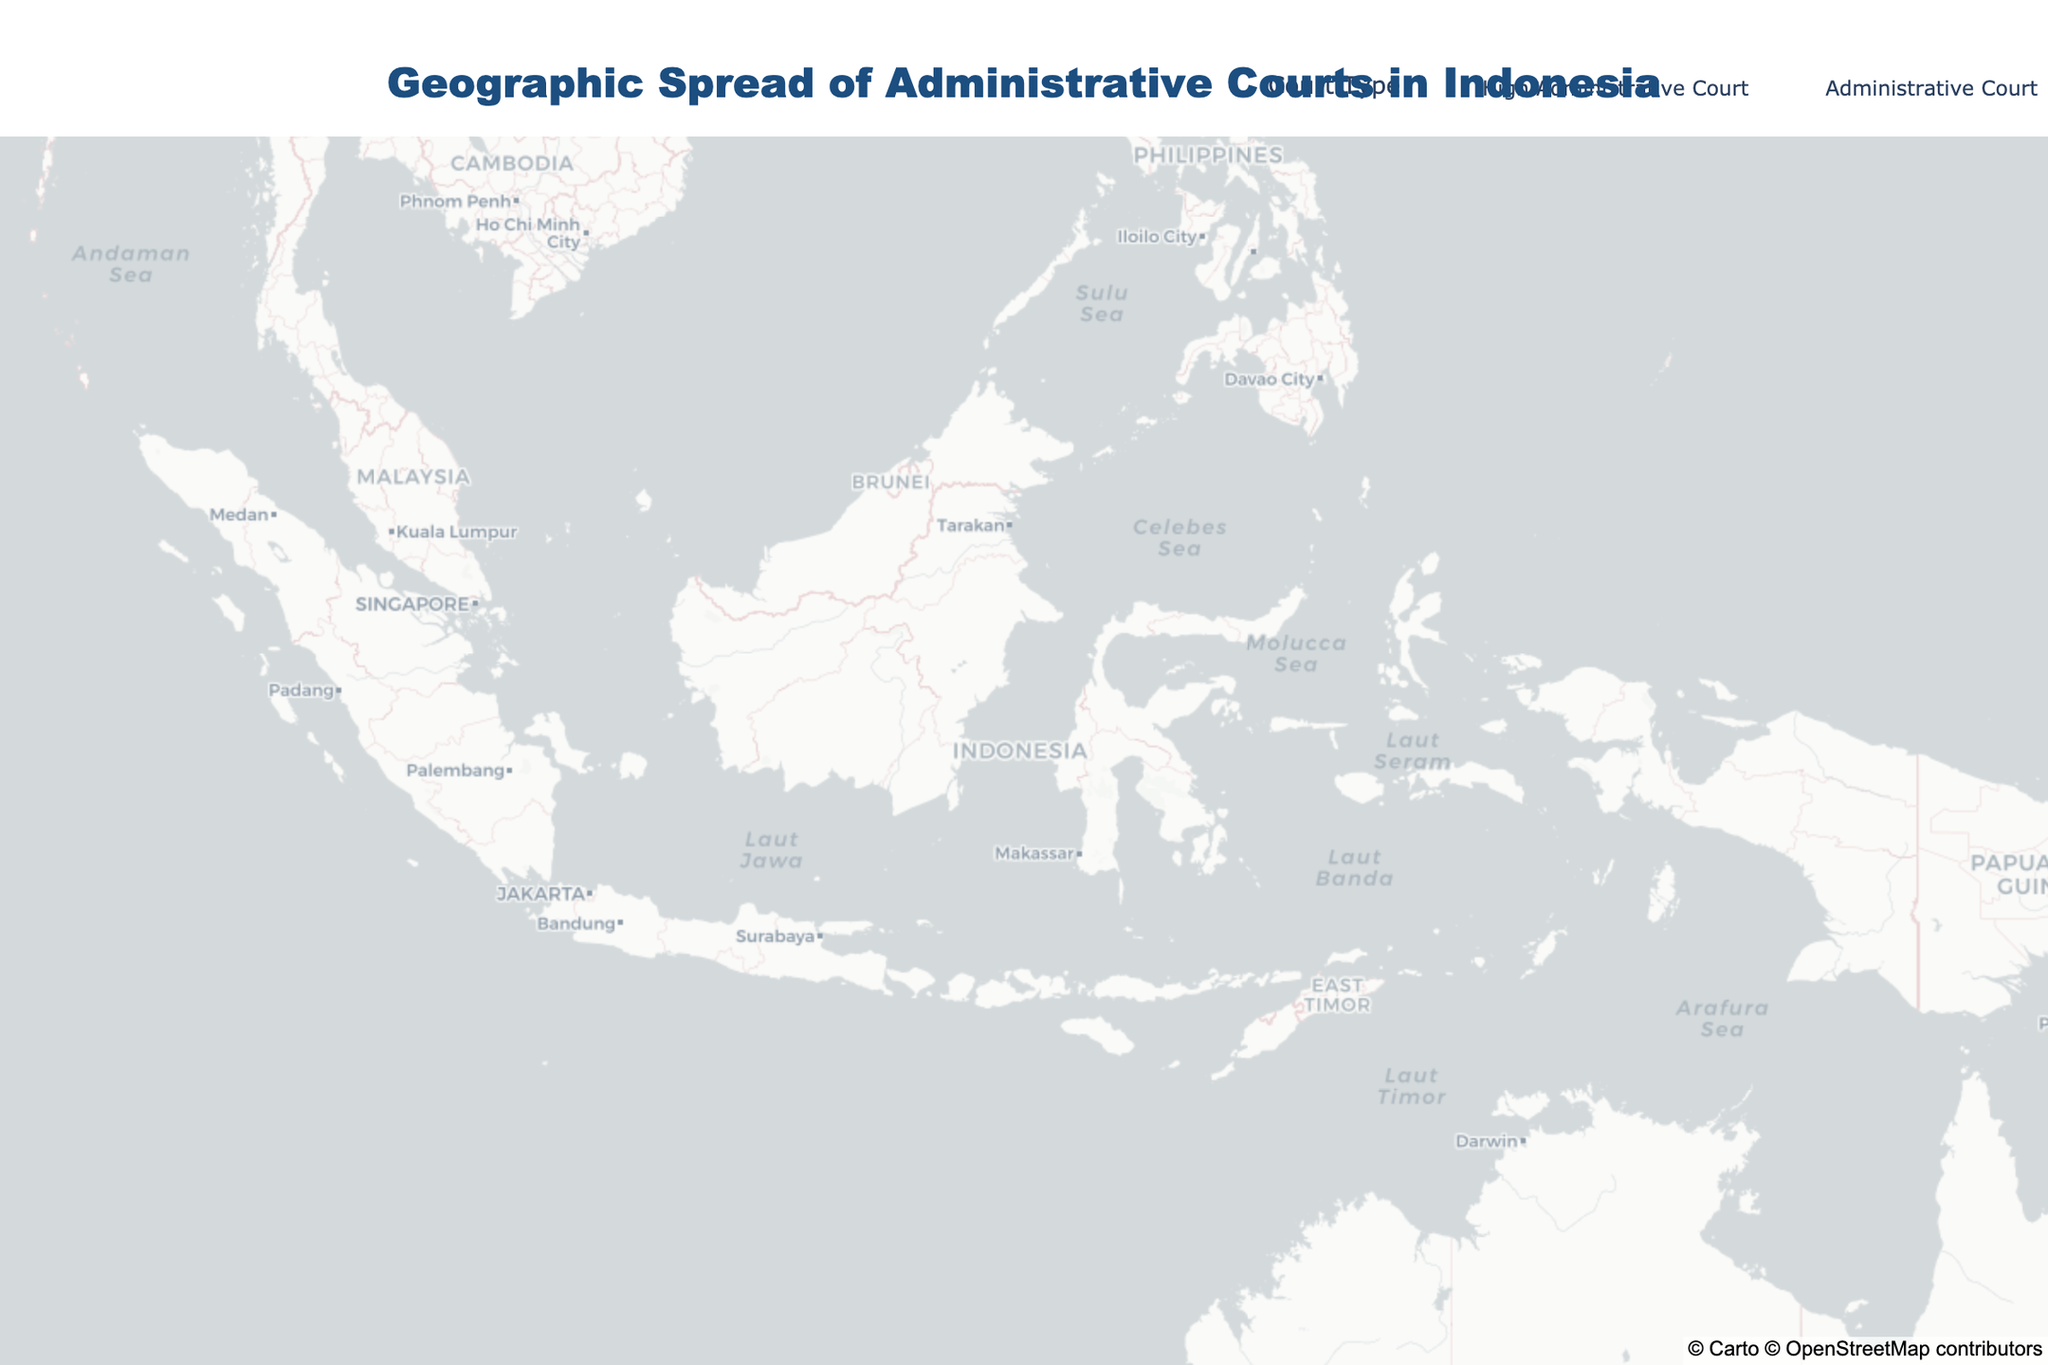What's the title of the figure? The title can be found at the top of the figure. By reading it, we know it is "Geographic Spread of Administrative Courts in Indonesia."
Answer: Geographic Spread of Administrative Courts in Indonesia How many administrative courts are there in Indonesia according to the figure? Count the number of data points marked on the map. There are 14 data points representing administrative courts.
Answer: 14 Which city hosts the High Administrative Court? The color and hover information differentiate High Administrative Court from regular Administrative Courts. From the hover data, Jakarta is the city that hosts the High Administrative Court.
Answer: Jakarta Which province has the most administrative courts based on the plot? Identify the province associated with each court from hover data and count the occurrences. Provinces with one administrative court each are DKI Jakarta, East Java, North Sumatra, South Sulawesi, West Java, Central Java, South Sumatra, Riau, Bali, South Kalimantan, Special Region of Yogyakarta, West Sumatra, North Sulawesi, West Kalimantan, and Maluku. No province has more than one court.
Answer: No single province has more than one court Are there any administrative courts in Kalimantan? Check the map for courts located on the island of Kalimantan by matching hover data with its coordinates. There are courts in Banjarmasin and Pontianak, indicating administrative courts on Kalimantan.
Answer: Yes, Banjarmasin and Pontianak How many administrative courts are there in Sumatra? Review the courts located on the island of Sumatra from the map and hover data. There are courts in Medan, Palembang, Pekanbaru, and Padang, making it four courts in Sumatra.
Answer: 4 Which court is further east: the one in Manado or Ambon? Compare the longitude of both cities. Manado (124.8421) is further east compared to Ambon (128.1814).
Answer: Ambon Which administrative court is nearest to the equator? By looking at the latitude values, which are the closest to 0. Pekanbaru, with a latitude of 0.5071, is nearest to the equator.
Answer: Pekanbaru Are there more administrative courts on the islands of Java or Sulawesi? Count the number of courts on Java (Jakarta, Surabaya, Bandung, Semarang, Yogyakarta) and Sulawesi (Makassar, Manado). There are 5 courts on Java and 2 courts on Sulawesi.
Answer: Java Which city in Java has an administrative court? The cities listed in Java are Jakarta, Surabaya, Bandung, Semarang, and Yogyakarta. All these cities have administrative courts based on the map.
Answer: Jakarta, Surabaya, Bandung, Semarang, Yogyakarta 